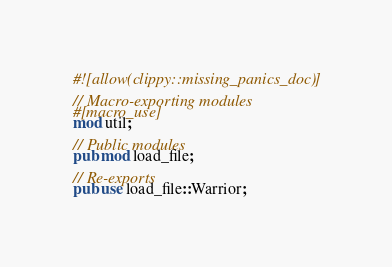<code> <loc_0><loc_0><loc_500><loc_500><_Rust_>#![allow(clippy::missing_panics_doc)]

// Macro-exporting modules
#[macro_use]
mod util;

// Public modules
pub mod load_file;

// Re-exports
pub use load_file::Warrior;
</code> 